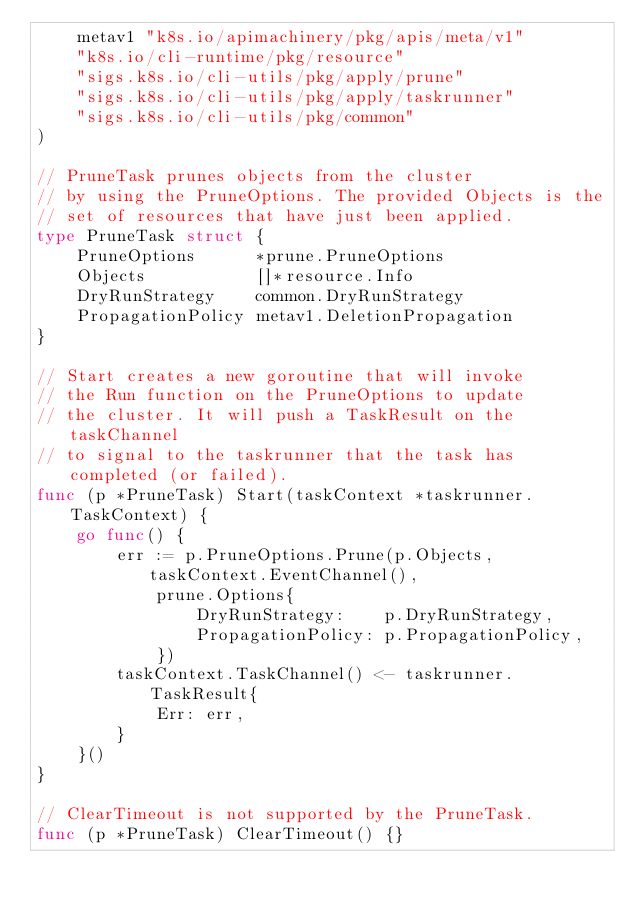<code> <loc_0><loc_0><loc_500><loc_500><_Go_>	metav1 "k8s.io/apimachinery/pkg/apis/meta/v1"
	"k8s.io/cli-runtime/pkg/resource"
	"sigs.k8s.io/cli-utils/pkg/apply/prune"
	"sigs.k8s.io/cli-utils/pkg/apply/taskrunner"
	"sigs.k8s.io/cli-utils/pkg/common"
)

// PruneTask prunes objects from the cluster
// by using the PruneOptions. The provided Objects is the
// set of resources that have just been applied.
type PruneTask struct {
	PruneOptions      *prune.PruneOptions
	Objects           []*resource.Info
	DryRunStrategy    common.DryRunStrategy
	PropagationPolicy metav1.DeletionPropagation
}

// Start creates a new goroutine that will invoke
// the Run function on the PruneOptions to update
// the cluster. It will push a TaskResult on the taskChannel
// to signal to the taskrunner that the task has completed (or failed).
func (p *PruneTask) Start(taskContext *taskrunner.TaskContext) {
	go func() {
		err := p.PruneOptions.Prune(p.Objects, taskContext.EventChannel(),
			prune.Options{
				DryRunStrategy:    p.DryRunStrategy,
				PropagationPolicy: p.PropagationPolicy,
			})
		taskContext.TaskChannel() <- taskrunner.TaskResult{
			Err: err,
		}
	}()
}

// ClearTimeout is not supported by the PruneTask.
func (p *PruneTask) ClearTimeout() {}
</code> 